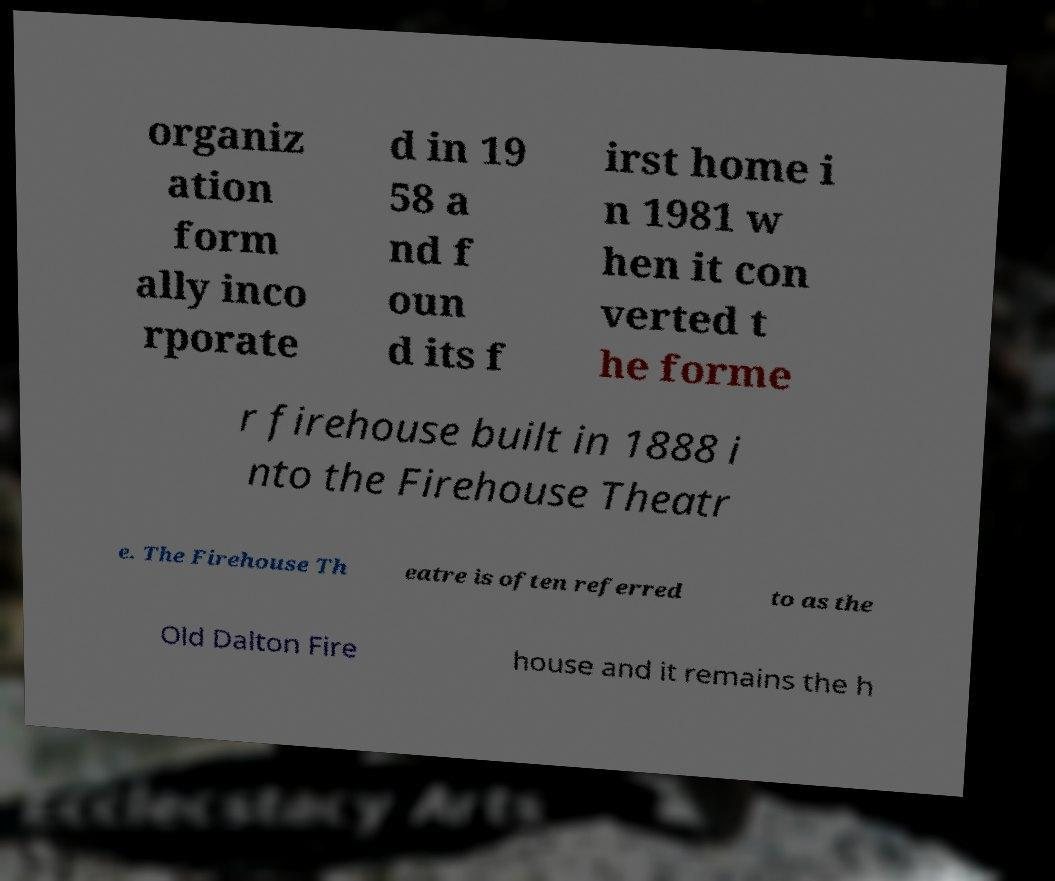What messages or text are displayed in this image? I need them in a readable, typed format. organiz ation form ally inco rporate d in 19 58 a nd f oun d its f irst home i n 1981 w hen it con verted t he forme r firehouse built in 1888 i nto the Firehouse Theatr e. The Firehouse Th eatre is often referred to as the Old Dalton Fire house and it remains the h 